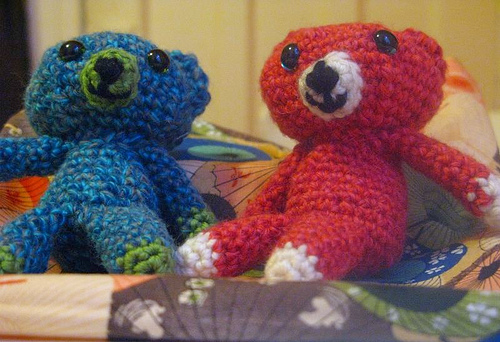<image>
Can you confirm if the bear is on the wall? No. The bear is not positioned on the wall. They may be near each other, but the bear is not supported by or resting on top of the wall. 